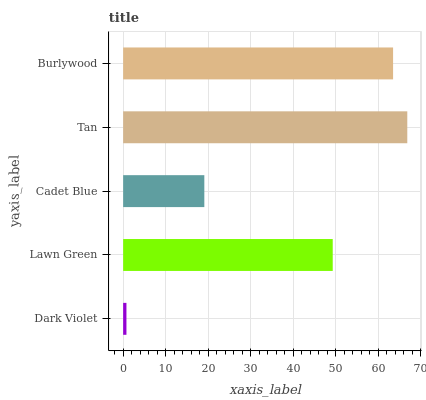Is Dark Violet the minimum?
Answer yes or no. Yes. Is Tan the maximum?
Answer yes or no. Yes. Is Lawn Green the minimum?
Answer yes or no. No. Is Lawn Green the maximum?
Answer yes or no. No. Is Lawn Green greater than Dark Violet?
Answer yes or no. Yes. Is Dark Violet less than Lawn Green?
Answer yes or no. Yes. Is Dark Violet greater than Lawn Green?
Answer yes or no. No. Is Lawn Green less than Dark Violet?
Answer yes or no. No. Is Lawn Green the high median?
Answer yes or no. Yes. Is Lawn Green the low median?
Answer yes or no. Yes. Is Cadet Blue the high median?
Answer yes or no. No. Is Cadet Blue the low median?
Answer yes or no. No. 